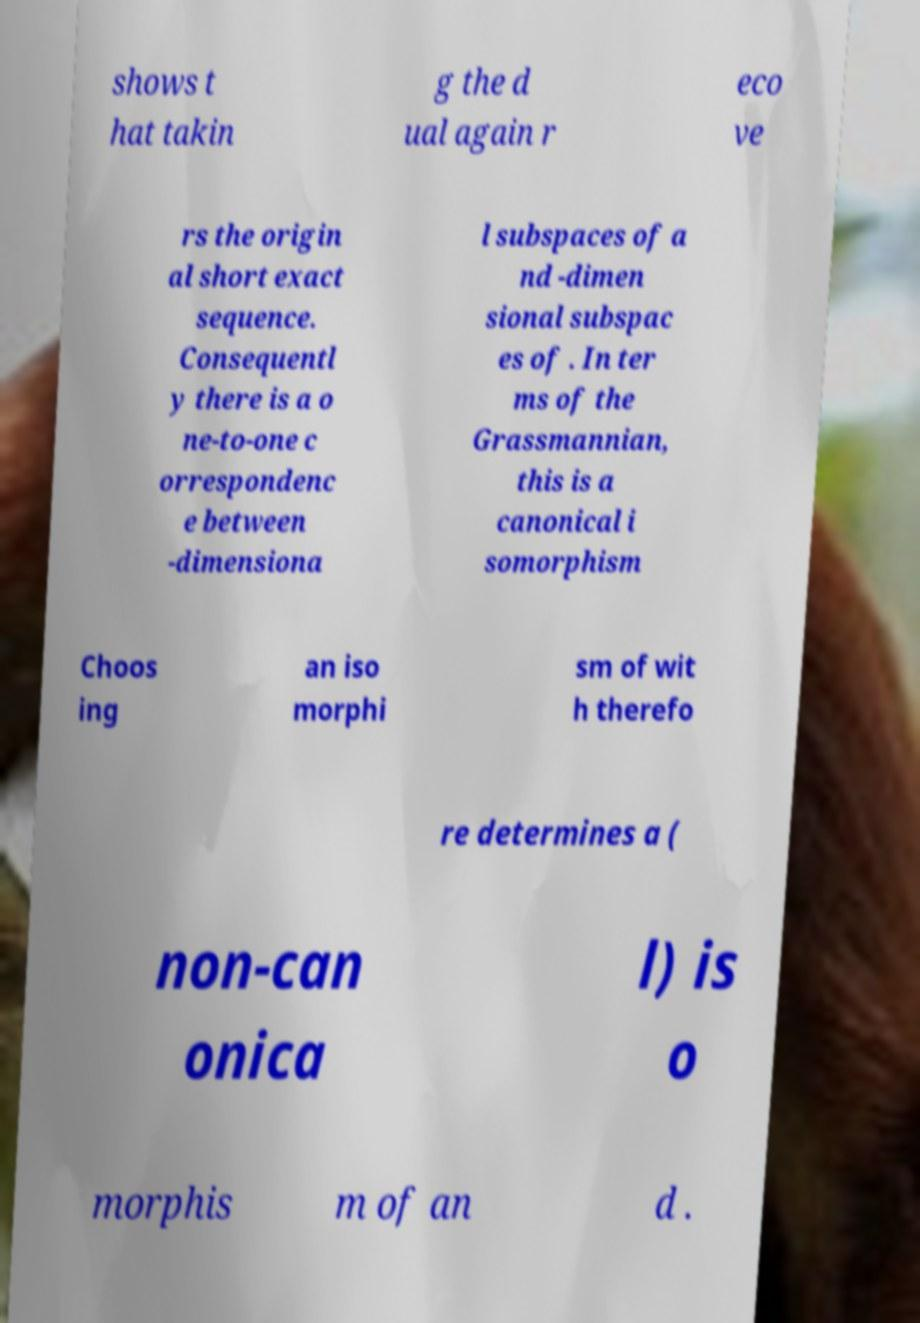There's text embedded in this image that I need extracted. Can you transcribe it verbatim? shows t hat takin g the d ual again r eco ve rs the origin al short exact sequence. Consequentl y there is a o ne-to-one c orrespondenc e between -dimensiona l subspaces of a nd -dimen sional subspac es of . In ter ms of the Grassmannian, this is a canonical i somorphism Choos ing an iso morphi sm of wit h therefo re determines a ( non-can onica l) is o morphis m of an d . 